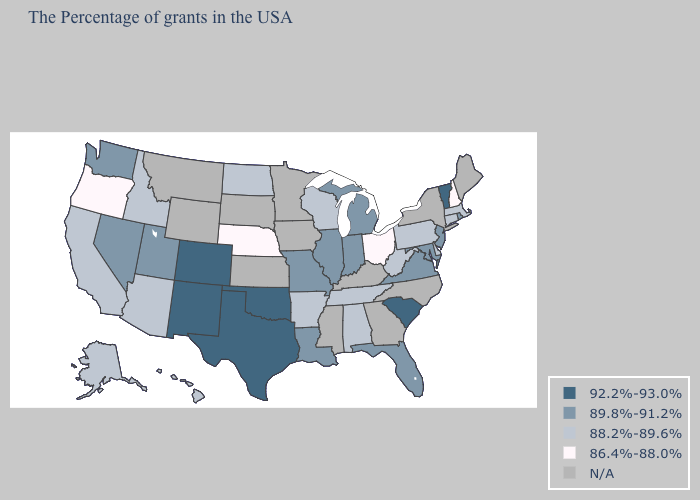Name the states that have a value in the range 88.2%-89.6%?
Give a very brief answer. Massachusetts, Connecticut, Delaware, Pennsylvania, West Virginia, Alabama, Tennessee, Wisconsin, Arkansas, North Dakota, Arizona, Idaho, California, Alaska, Hawaii. Does Massachusetts have the lowest value in the Northeast?
Be succinct. No. What is the value of Illinois?
Answer briefly. 89.8%-91.2%. What is the value of South Dakota?
Write a very short answer. N/A. Name the states that have a value in the range 92.2%-93.0%?
Write a very short answer. Vermont, South Carolina, Oklahoma, Texas, Colorado, New Mexico. What is the value of Kansas?
Quick response, please. N/A. What is the value of Nevada?
Concise answer only. 89.8%-91.2%. Name the states that have a value in the range N/A?
Concise answer only. Maine, New York, North Carolina, Georgia, Kentucky, Mississippi, Minnesota, Iowa, Kansas, South Dakota, Wyoming, Montana. What is the highest value in states that border Alabama?
Short answer required. 89.8%-91.2%. Name the states that have a value in the range 88.2%-89.6%?
Answer briefly. Massachusetts, Connecticut, Delaware, Pennsylvania, West Virginia, Alabama, Tennessee, Wisconsin, Arkansas, North Dakota, Arizona, Idaho, California, Alaska, Hawaii. Name the states that have a value in the range 89.8%-91.2%?
Answer briefly. Rhode Island, New Jersey, Maryland, Virginia, Florida, Michigan, Indiana, Illinois, Louisiana, Missouri, Utah, Nevada, Washington. Does Wisconsin have the highest value in the MidWest?
Concise answer only. No. What is the value of Kansas?
Be succinct. N/A. 